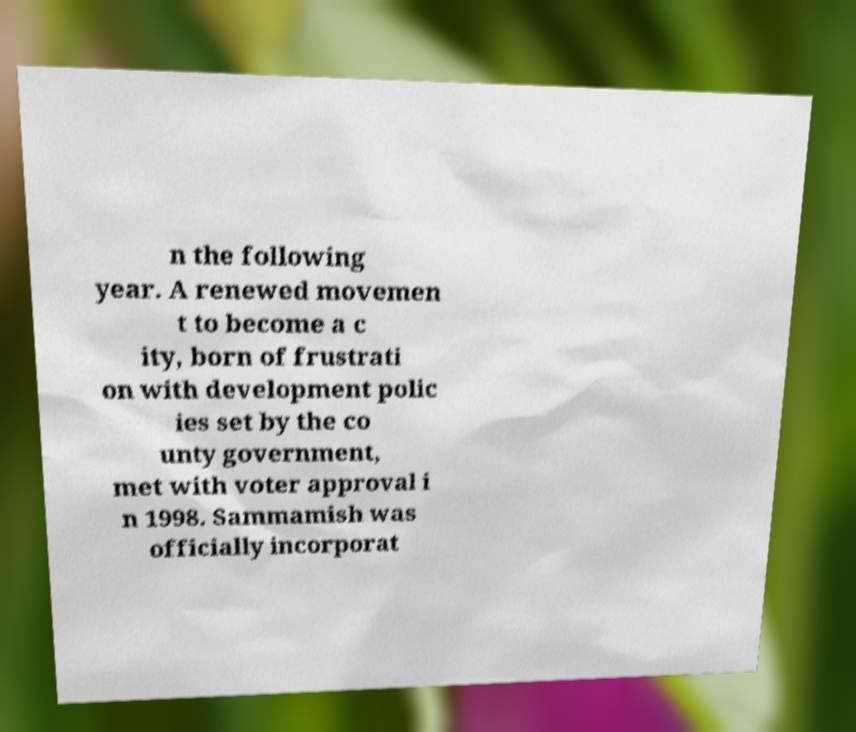Please read and relay the text visible in this image. What does it say? n the following year. A renewed movemen t to become a c ity, born of frustrati on with development polic ies set by the co unty government, met with voter approval i n 1998. Sammamish was officially incorporat 